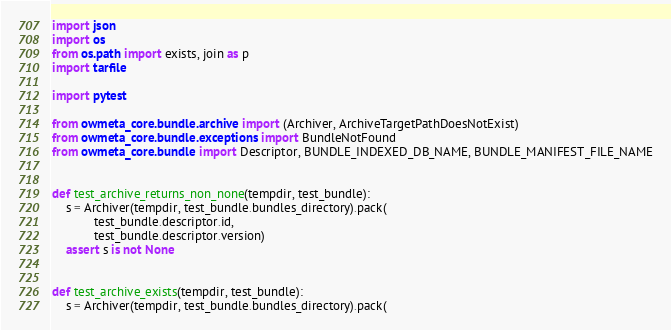<code> <loc_0><loc_0><loc_500><loc_500><_Python_>import json
import os
from os.path import exists, join as p
import tarfile

import pytest

from owmeta_core.bundle.archive import (Archiver, ArchiveTargetPathDoesNotExist)
from owmeta_core.bundle.exceptions import BundleNotFound
from owmeta_core.bundle import Descriptor, BUNDLE_INDEXED_DB_NAME, BUNDLE_MANIFEST_FILE_NAME


def test_archive_returns_non_none(tempdir, test_bundle):
    s = Archiver(tempdir, test_bundle.bundles_directory).pack(
            test_bundle.descriptor.id,
            test_bundle.descriptor.version)
    assert s is not None


def test_archive_exists(tempdir, test_bundle):
    s = Archiver(tempdir, test_bundle.bundles_directory).pack(</code> 